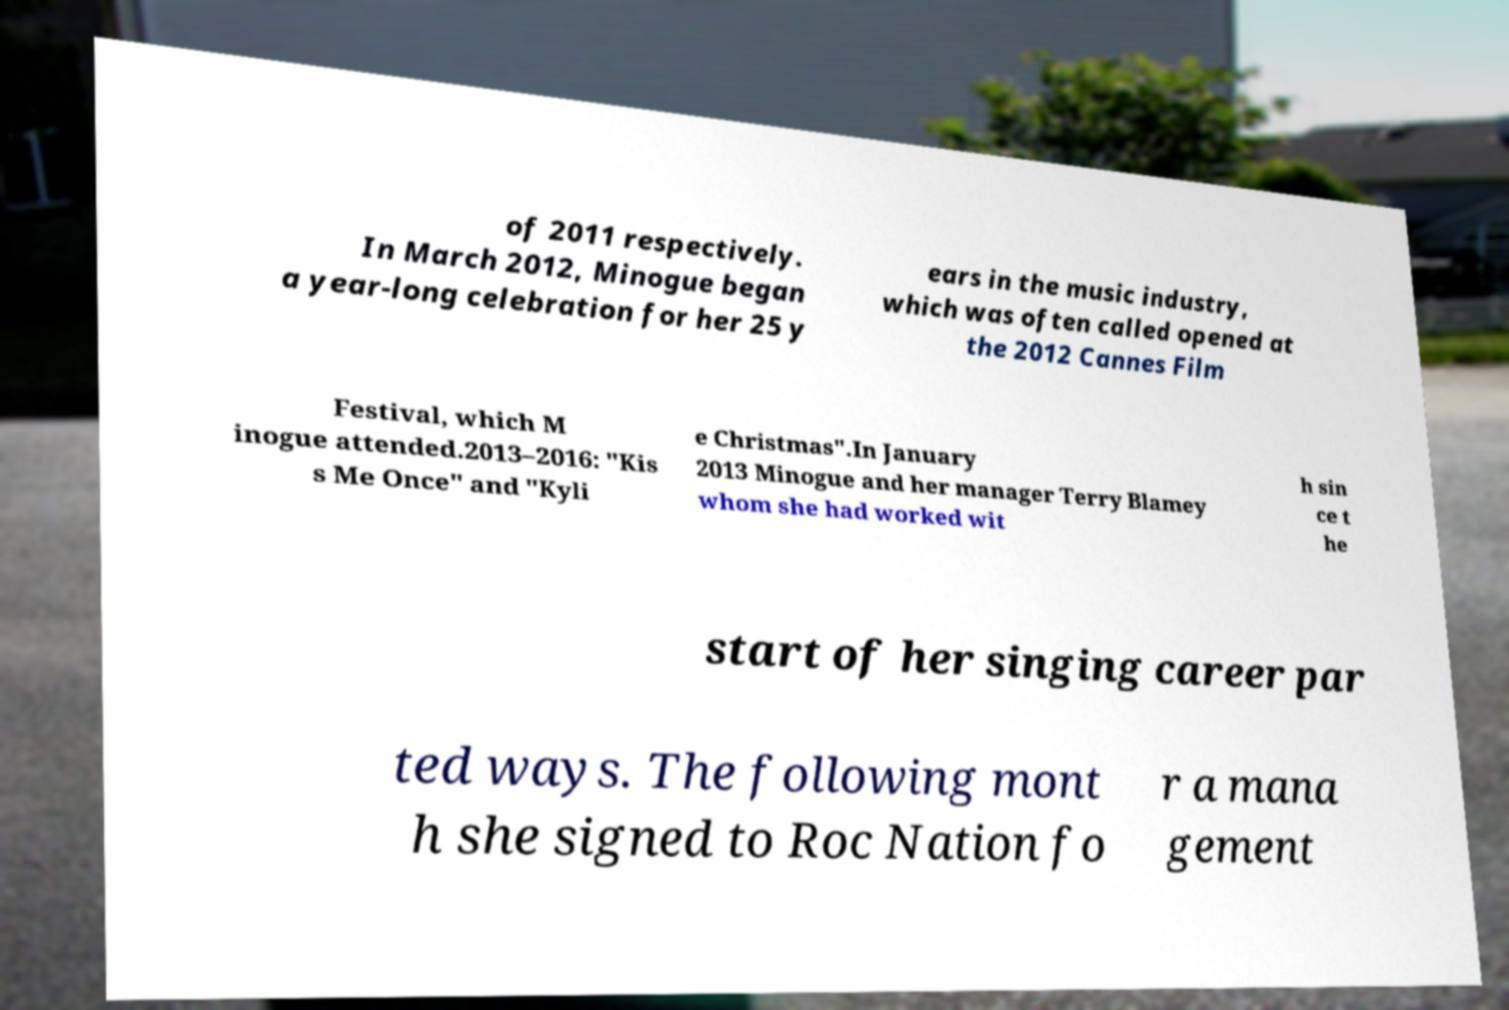Could you extract and type out the text from this image? of 2011 respectively. In March 2012, Minogue began a year-long celebration for her 25 y ears in the music industry, which was often called opened at the 2012 Cannes Film Festival, which M inogue attended.2013–2016: "Kis s Me Once" and "Kyli e Christmas".In January 2013 Minogue and her manager Terry Blamey whom she had worked wit h sin ce t he start of her singing career par ted ways. The following mont h she signed to Roc Nation fo r a mana gement 